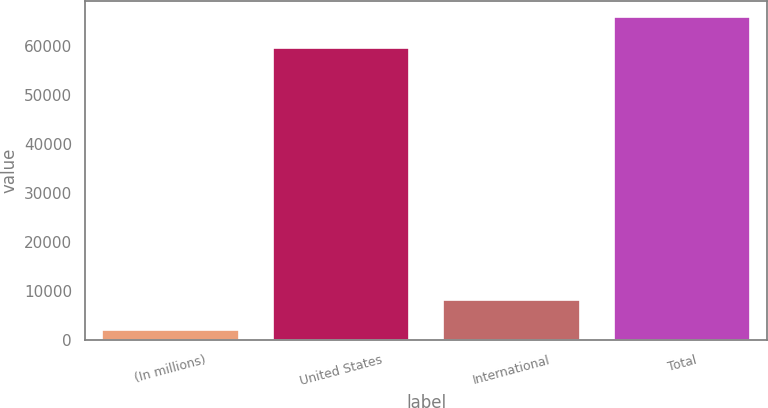<chart> <loc_0><loc_0><loc_500><loc_500><bar_chart><fcel>(In millions)<fcel>United States<fcel>International<fcel>Total<nl><fcel>2006<fcel>59723<fcel>8295<fcel>66012<nl></chart> 